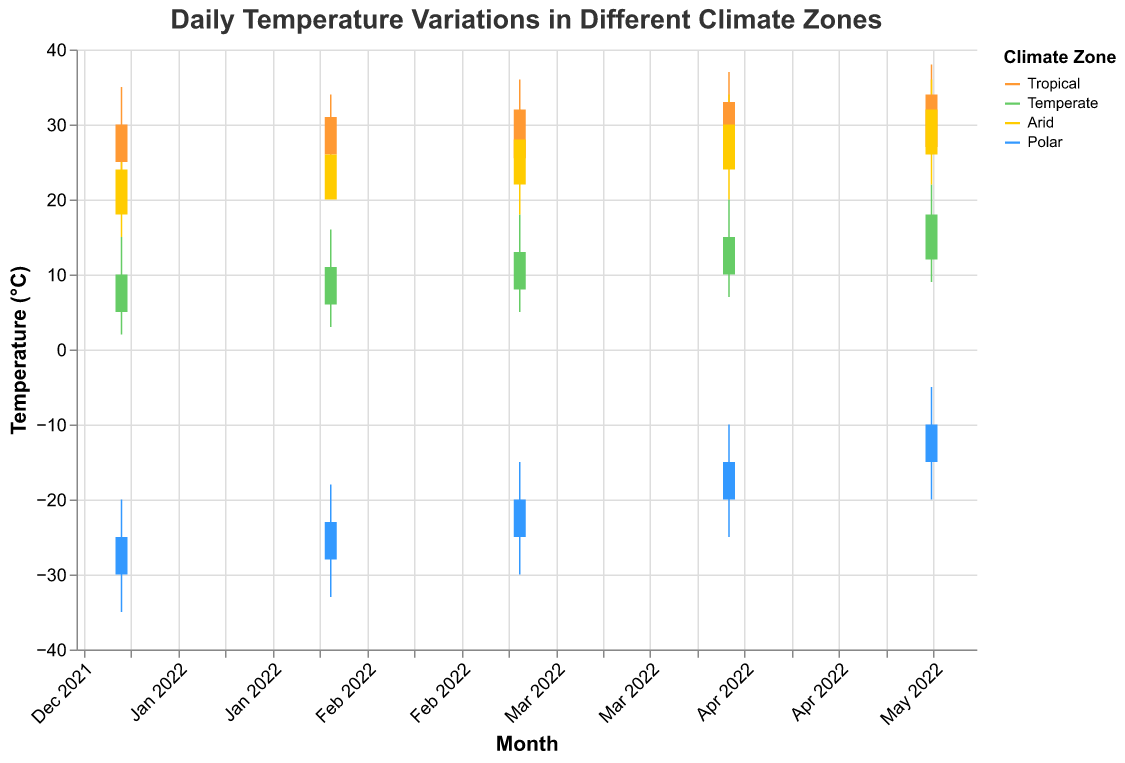What is the title of the candlestick plot? The title is prominently displayed at the top of the candlestick plot and provides a summary of what the data represents. In this case, the title tells us that the plot is about daily temperature variations in different climate zones over a year.
Answer: Daily Temperature Variations in Different Climate Zones How many climate zones are represented in the plot? There are four distinct colors represented in the plot's color legend, each corresponding to one of the climate zones: Tropical, Temperate, Arid, and Polar.
Answer: 4 Which climate zone has the highest high temperature in May 2022? By examining the candlesticks for May 2022, you can see that the Tropical climate zone has the highest high temperature of 38.0°C.
Answer: Tropical What is the temperature range for the Polar climate zone in January 2022? The temperature range is the difference between the high and low values. For the Polar climate zone in January 2022: high is -20.0°C and low is -35.0°C. The range is -20.0 - (-35.0) = 15.0°C.
Answer: 15.0°C What was the close temperature for the Temperate climate zone in March 2022? The close temperature is represented by the end point of the candlestick's body. For the Temperate climate zone in March 2022, the close temperature is 13.0°C.
Answer: 13.0°C Which climate zone shows the smallest difference between open and close temperatures in February 2022? To find the smallest difference between open and close temperatures, we compare the differences for each climate zone: Tropical (26.0 - 31.0 = 5.0), Temperate (6.0 - 11.0 = 5.0), Arid (20.0 - 26.0 = 6.0), and Polar (-28.0 - (-23.0) = 5.0). All zones except Arid have a difference of 5.0°C, making them the climate zones with the smallest difference.
Answer: Tropical, Temperate, Polar How has the open temperature for the Arid climate zone changed from January 2022 to May 2022? By evaluating the candlesticks for the Arid climate zone, the open temperatures are: January 18.0°C, February 20.0°C, March 22.0°C, April 24.0°C, and May 26.0°C. The change is 26.0 - 18.0 = 8.0°C.
Answer: 8.0°C Which climate zone has the largest open temperature in April 2022? By looking at the candlesticks for April 2022, the Tropical climate zone has the largest open temperature at 26.5°C.
Answer: Tropical What is the average low temperature in March 2022 across all climate zones? The low temperatures for March 2022 are: Tropical (24.0°C), Temperate (5.0°C), Arid (18.0°C), Polar (-30.0°C). Average = (24.0 + 5.0 + 18.0 - 30.0) / 4 = 4.25°C.
Answer: 4.25°C Which climate zone has the most consistent (smallest range in) temperature variation in April 2022? To find the most consistent temperature variation, calculate the range (High - Low) for each zone in April 2022: Tropical (37.0 - 25.0 = 12.0), Temperate (20.0 - 7.0 = 13.0), Arid (34.0 - 20.0 = 14.0), Polar (-10.0 - (-25.0) = 15.0). Tropical has the smallest range at 12.0.
Answer: Tropical 